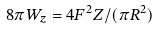Convert formula to latex. <formula><loc_0><loc_0><loc_500><loc_500>8 \pi W _ { z } = 4 F ^ { 2 } Z / ( \pi R ^ { 2 } )</formula> 